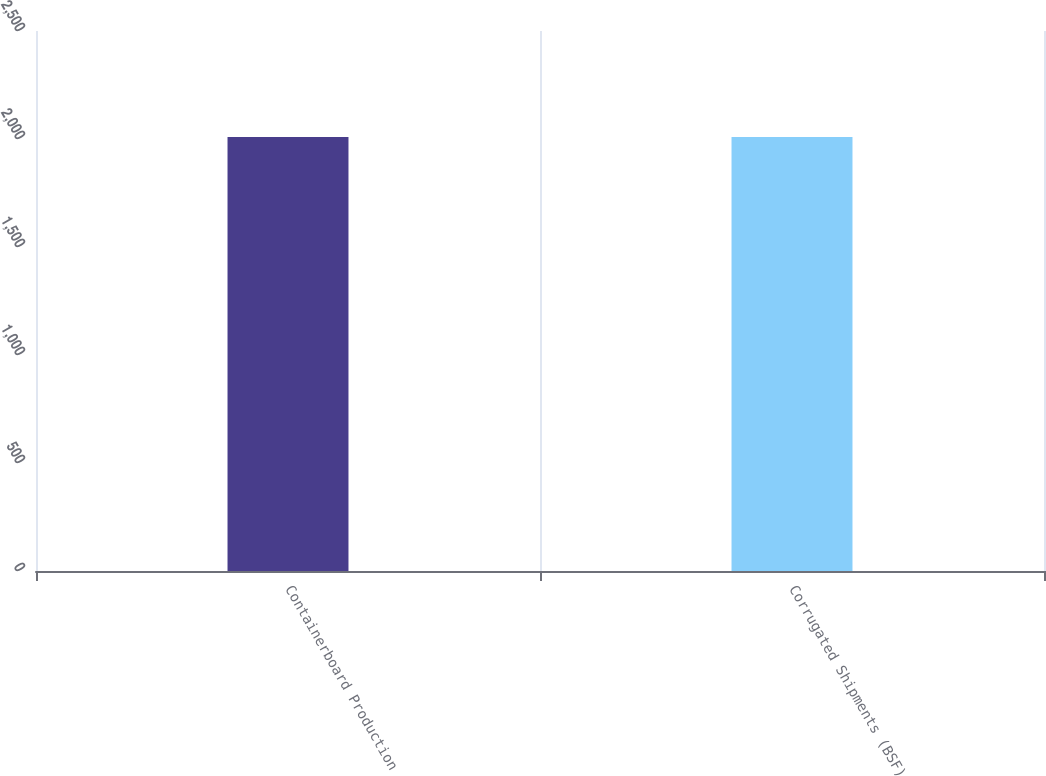<chart> <loc_0><loc_0><loc_500><loc_500><bar_chart><fcel>Containerboard Production<fcel>Corrugated Shipments (BSF)<nl><fcel>2009<fcel>2009.1<nl></chart> 